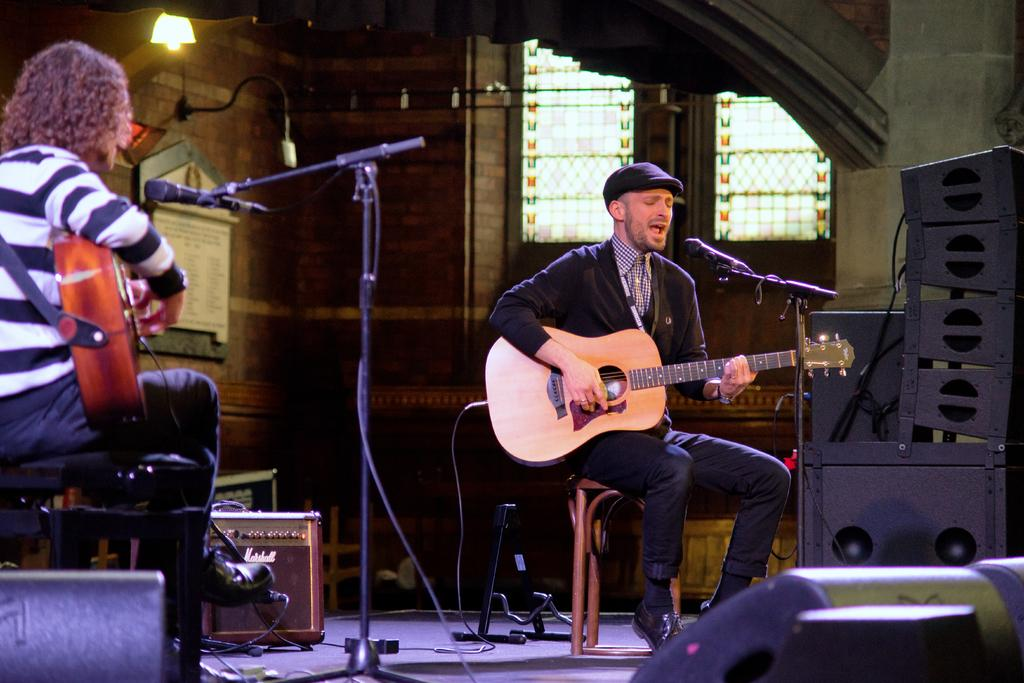How many people are present in the image? There are two people seated in the image. What are the two people doing? The two people are playing guitar. Is there anyone else performing in the image? Yes, there is a man singing in the image. How is the man singing in the image? The man is using a microphone while singing. Can you see any spots on the guitar in the image? There is no mention of spots on the guitar in the image, so we cannot determine if any are present. 